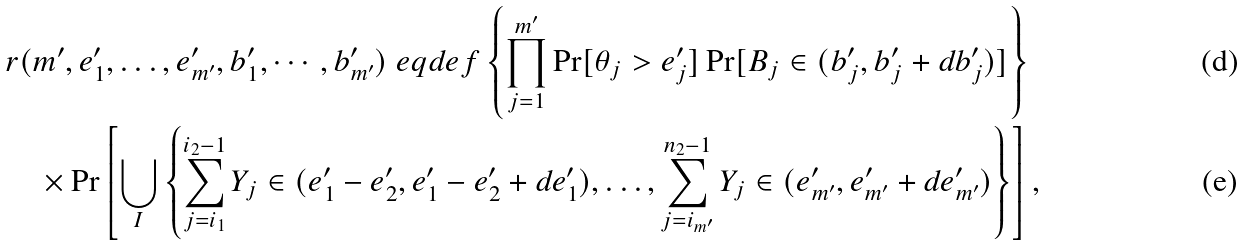Convert formula to latex. <formula><loc_0><loc_0><loc_500><loc_500>& r ( m ^ { \prime } , e ^ { \prime } _ { 1 } , \dots , e ^ { \prime } _ { m ^ { \prime } } , b ^ { \prime } _ { 1 } , \cdots , b ^ { \prime } _ { m ^ { \prime } } ) \ e q d e f \left \{ \prod _ { j = 1 } ^ { m ^ { \prime } } \Pr [ \theta _ { j } > e ^ { \prime } _ { j } ] \Pr [ B _ { j } \in ( b ^ { \prime } _ { j } , b ^ { \prime } _ { j } + d b ^ { \prime } _ { j } ) ] \right \} \\ & \quad \times \Pr \left [ \bigcup _ { I } \left \{ \sum _ { j = i _ { 1 } } ^ { i _ { 2 } - 1 } Y _ { j } \in ( e ^ { \prime } _ { 1 } - e ^ { \prime } _ { 2 } , e ^ { \prime } _ { 1 } - e ^ { \prime } _ { 2 } + d e ^ { \prime } _ { 1 } ) , \dots , \sum _ { j = i _ { m ^ { \prime } } } ^ { n _ { 2 } - 1 } Y _ { j } \in ( e ^ { \prime } _ { m ^ { \prime } } , e ^ { \prime } _ { m ^ { \prime } } + d e ^ { \prime } _ { m ^ { \prime } } ) \right \} \right ] ,</formula> 